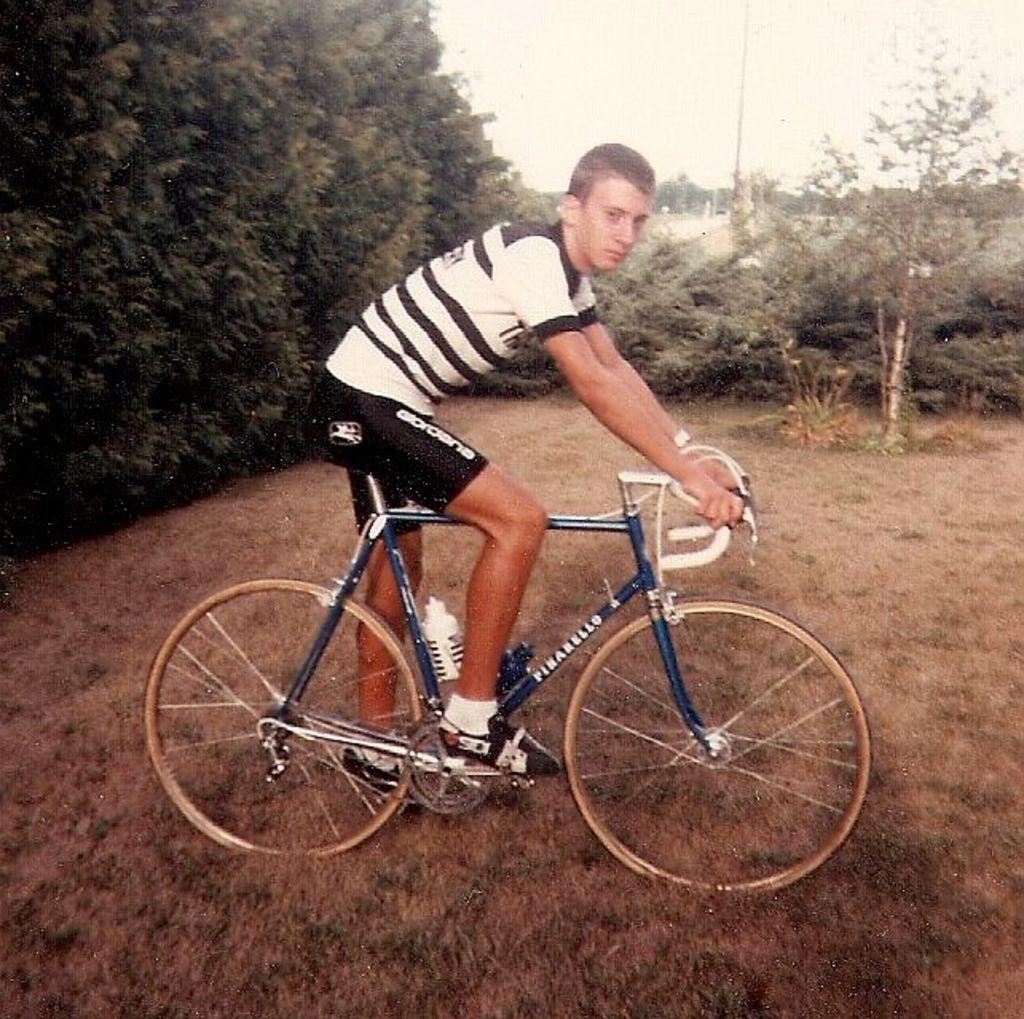Who or what is in the image? There is a person in the image. What is the person doing in the image? The person is sitting on a bicycle. Can you describe the bicycle? The bicycle is blue. What is the person wearing? The person is wearing a black and white t-shirt and shoes. What can be seen in the background of the image? There are trees and the sky visible in the background of the image. What type of wren can be seen perched on the handlebars of the bicycle in the image? There is no wren present in the image; it only features a person sitting on a blue bicycle. What team does the person in the image belong to? There is no indication of the person belonging to a team in the image. 